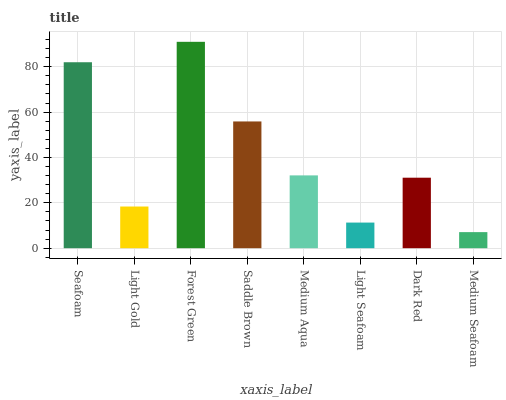Is Medium Seafoam the minimum?
Answer yes or no. Yes. Is Forest Green the maximum?
Answer yes or no. Yes. Is Light Gold the minimum?
Answer yes or no. No. Is Light Gold the maximum?
Answer yes or no. No. Is Seafoam greater than Light Gold?
Answer yes or no. Yes. Is Light Gold less than Seafoam?
Answer yes or no. Yes. Is Light Gold greater than Seafoam?
Answer yes or no. No. Is Seafoam less than Light Gold?
Answer yes or no. No. Is Medium Aqua the high median?
Answer yes or no. Yes. Is Dark Red the low median?
Answer yes or no. Yes. Is Light Gold the high median?
Answer yes or no. No. Is Light Gold the low median?
Answer yes or no. No. 